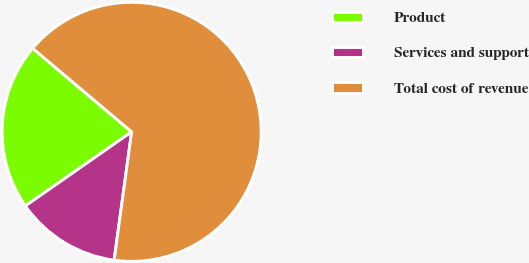Convert chart. <chart><loc_0><loc_0><loc_500><loc_500><pie_chart><fcel>Product<fcel>Services and support<fcel>Total cost of revenue<nl><fcel>20.85%<fcel>13.15%<fcel>66.0%<nl></chart> 